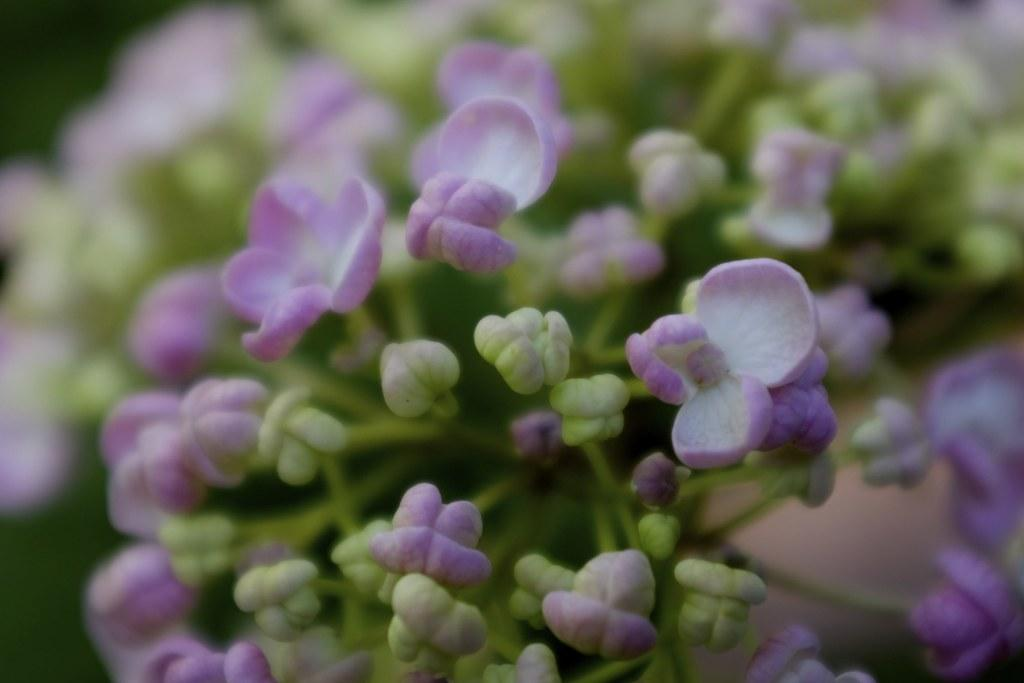What type of plants can be seen in the image? There are flowers in the image. Are there any unopened flowers in the image? Yes, there are buds in the image. Can you describe the background of the image? The background of the image is blurred. What time of day is depicted in the image? The image does not show any specific time of day, as it only features flowers and buds with a blurred background. 